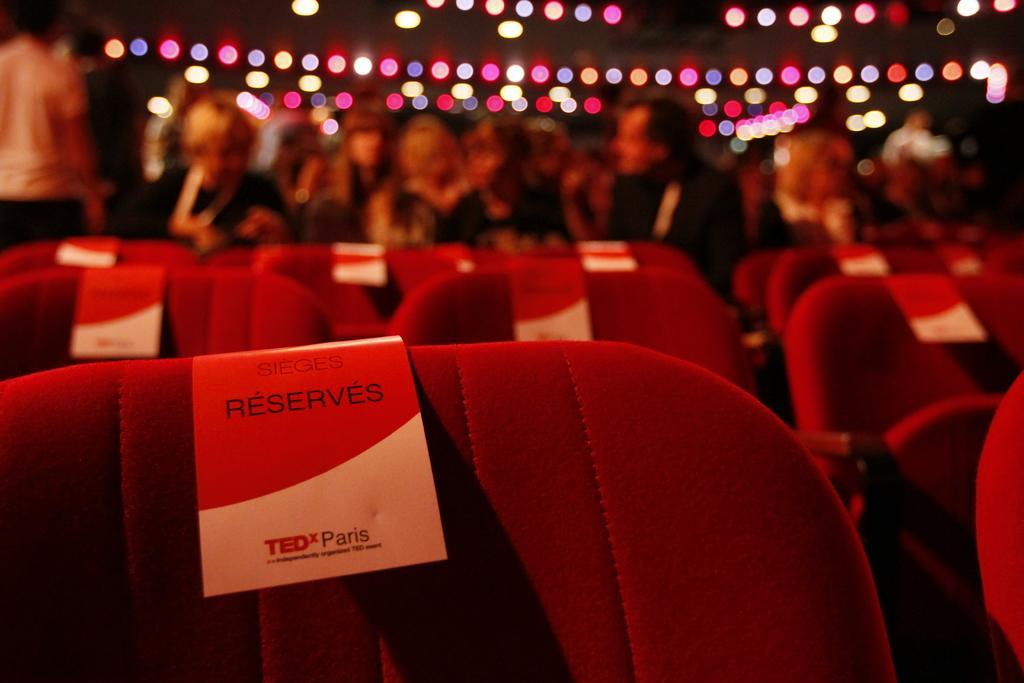In one or two sentences, can you explain what this image depicts? This is an image clicked in the dark. Here I can see many empty chairs. There are few pamphlets attached to the chairs. In the background there are many people and lights. 